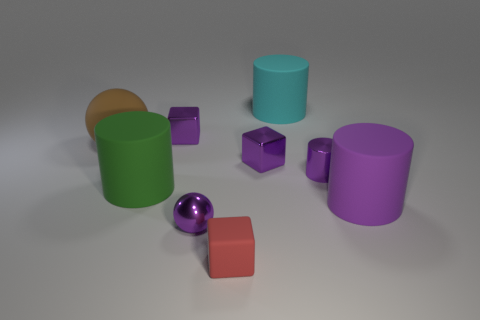Add 1 small brown matte blocks. How many objects exist? 10 Subtract all cyan rubber cylinders. How many cylinders are left? 3 Subtract all green cylinders. How many cylinders are left? 3 Subtract all cylinders. How many objects are left? 5 Subtract 2 cubes. How many cubes are left? 1 Add 7 cyan matte things. How many cyan matte things are left? 8 Add 7 big cyan metal cylinders. How many big cyan metal cylinders exist? 7 Subtract 0 blue blocks. How many objects are left? 9 Subtract all yellow cubes. Subtract all blue cylinders. How many cubes are left? 3 Subtract all green cubes. How many cyan spheres are left? 0 